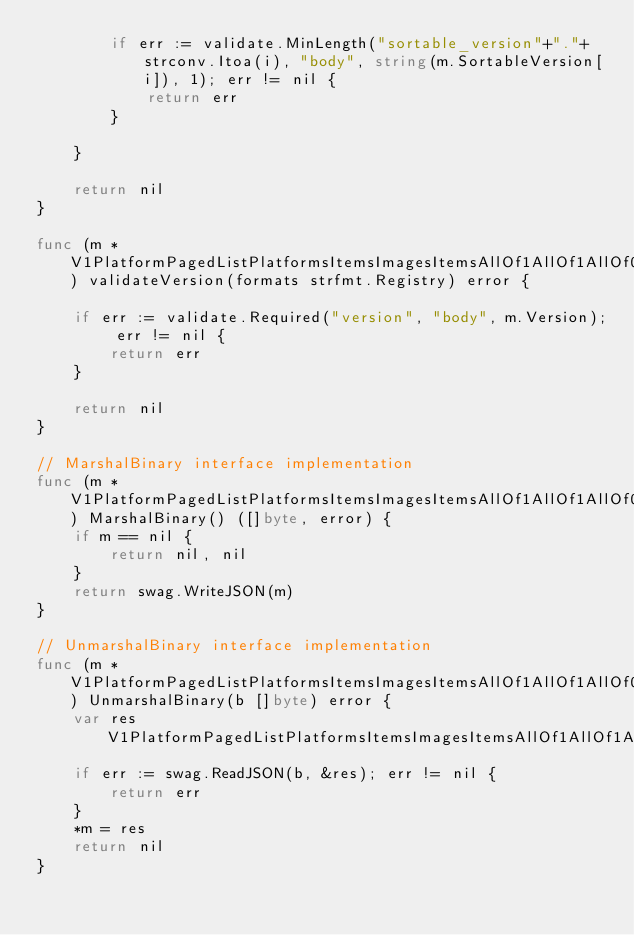Convert code to text. <code><loc_0><loc_0><loc_500><loc_500><_Go_>		if err := validate.MinLength("sortable_version"+"."+strconv.Itoa(i), "body", string(m.SortableVersion[i]), 1); err != nil {
			return err
		}

	}

	return nil
}

func (m *V1PlatformPagedListPlatformsItemsImagesItemsAllOf1AllOf1AllOf0) validateVersion(formats strfmt.Registry) error {

	if err := validate.Required("version", "body", m.Version); err != nil {
		return err
	}

	return nil
}

// MarshalBinary interface implementation
func (m *V1PlatformPagedListPlatformsItemsImagesItemsAllOf1AllOf1AllOf0) MarshalBinary() ([]byte, error) {
	if m == nil {
		return nil, nil
	}
	return swag.WriteJSON(m)
}

// UnmarshalBinary interface implementation
func (m *V1PlatformPagedListPlatformsItemsImagesItemsAllOf1AllOf1AllOf0) UnmarshalBinary(b []byte) error {
	var res V1PlatformPagedListPlatformsItemsImagesItemsAllOf1AllOf1AllOf0
	if err := swag.ReadJSON(b, &res); err != nil {
		return err
	}
	*m = res
	return nil
}
</code> 